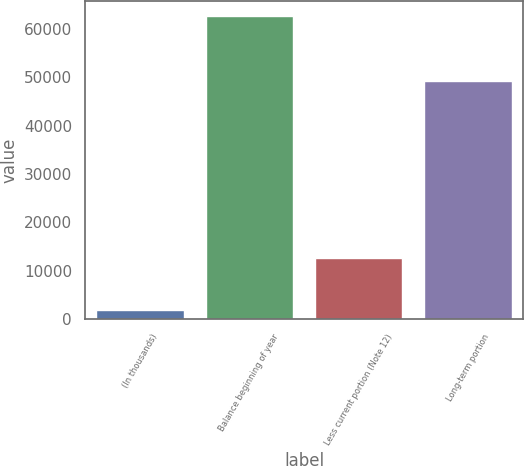Convert chart. <chart><loc_0><loc_0><loc_500><loc_500><bar_chart><fcel>(In thousands)<fcel>Balance beginning of year<fcel>Less current portion (Note 12)<fcel>Long-term portion<nl><fcel>2019<fcel>62551<fcel>12618<fcel>49301<nl></chart> 